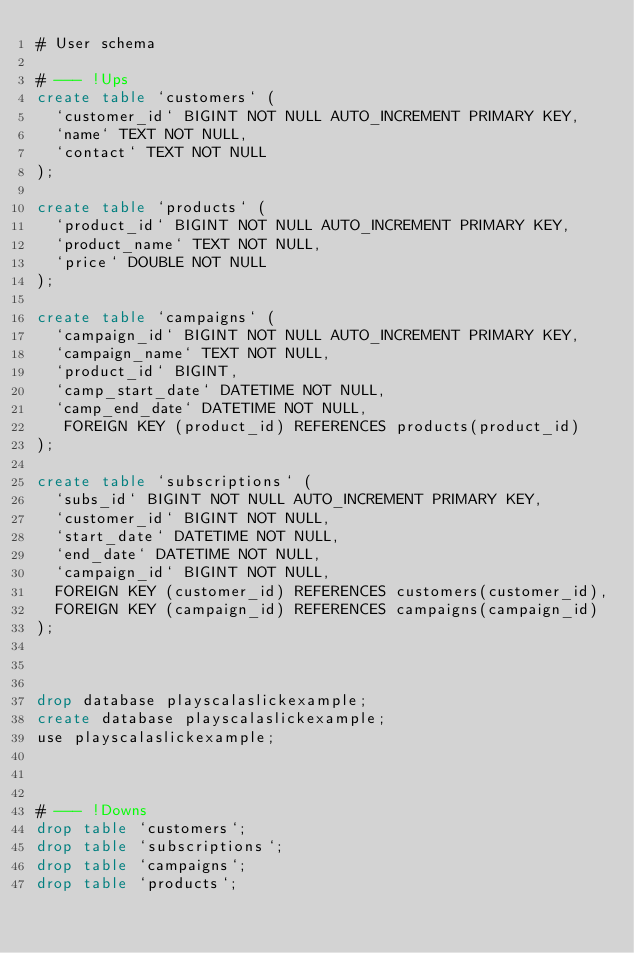Convert code to text. <code><loc_0><loc_0><loc_500><loc_500><_SQL_># User schema

# --- !Ups
create table `customers` (
  `customer_id` BIGINT NOT NULL AUTO_INCREMENT PRIMARY KEY,
  `name` TEXT NOT NULL,
  `contact` TEXT NOT NULL
);

create table `products` (
  `product_id` BIGINT NOT NULL AUTO_INCREMENT PRIMARY KEY,
  `product_name` TEXT NOT NULL,
  `price` DOUBLE NOT NULL
);

create table `campaigns` (
  `campaign_id` BIGINT NOT NULL AUTO_INCREMENT PRIMARY KEY,
  `campaign_name` TEXT NOT NULL,
  `product_id` BIGINT,
  `camp_start_date` DATETIME NOT NULL,
  `camp_end_date` DATETIME NOT NULL,
   FOREIGN KEY (product_id) REFERENCES products(product_id)
);

create table `subscriptions` (
  `subs_id` BIGINT NOT NULL AUTO_INCREMENT PRIMARY KEY,
  `customer_id` BIGINT NOT NULL,
  `start_date` DATETIME NOT NULL,
  `end_date` DATETIME NOT NULL,
  `campaign_id` BIGINT NOT NULL,
  FOREIGN KEY (customer_id) REFERENCES customers(customer_id),
  FOREIGN KEY (campaign_id) REFERENCES campaigns(campaign_id)
);



drop database playscalaslickexample;
create database playscalaslickexample;
use playscalaslickexample;



# --- !Downs
drop table `customers`;
drop table `subscriptions`;
drop table `campaigns`;
drop table `products`;</code> 